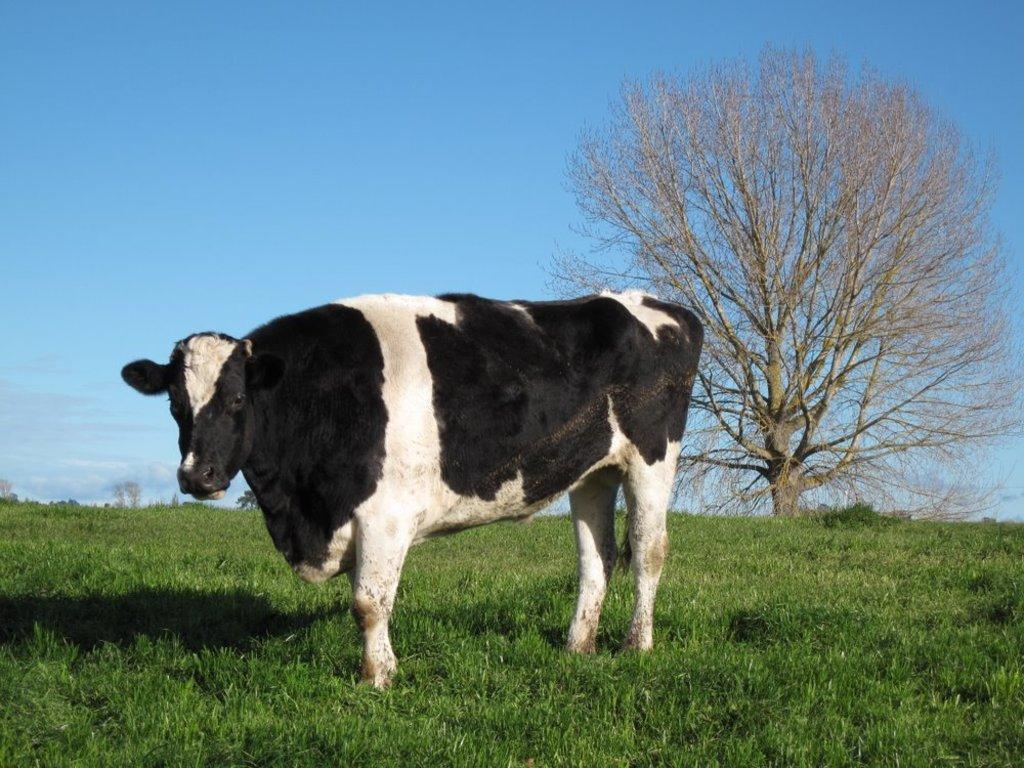What animal is on the grass in the image? There is a cow on the surface of the grass in the image. What type of vegetation is present in the image? There is a tree in the image. What can be seen in the background of the image? The sky is visible in the background of the image. How many chairs are visible in the image? There are no chairs present in the image. 